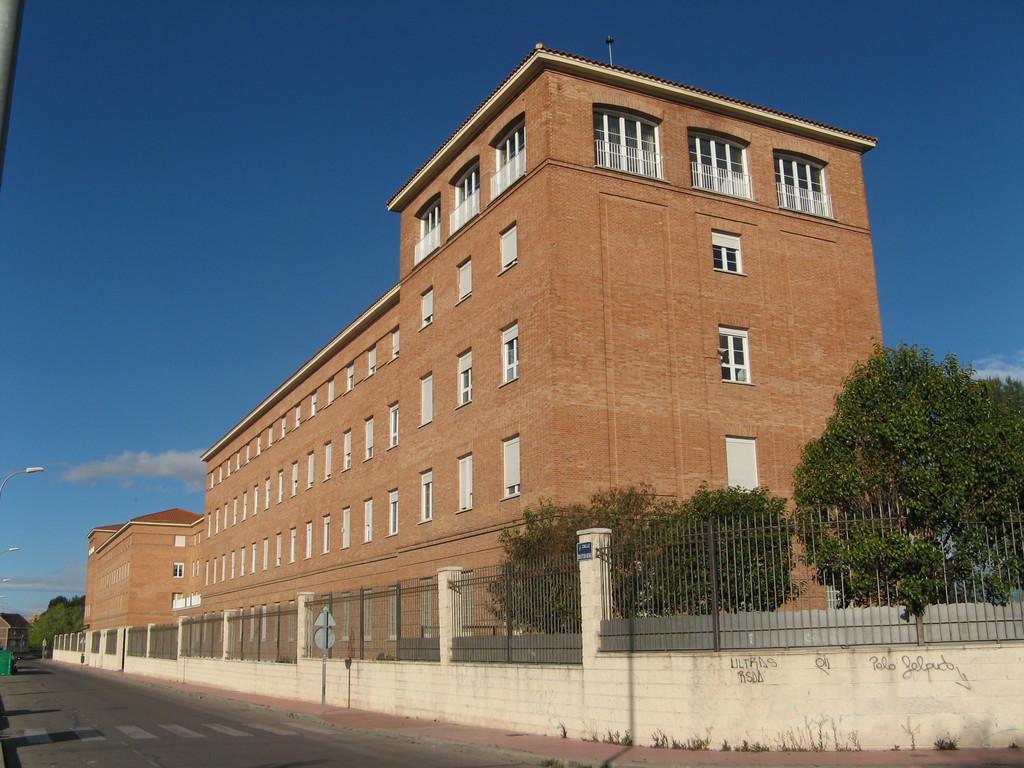How would you summarize this image in a sentence or two? In this image we can see some buildings with windows, roof and a fence. We can also see some trees and a sign board to a pole. On the left side we can see the road, a house with a roof, streetlights and the sky which looks cloudy. 